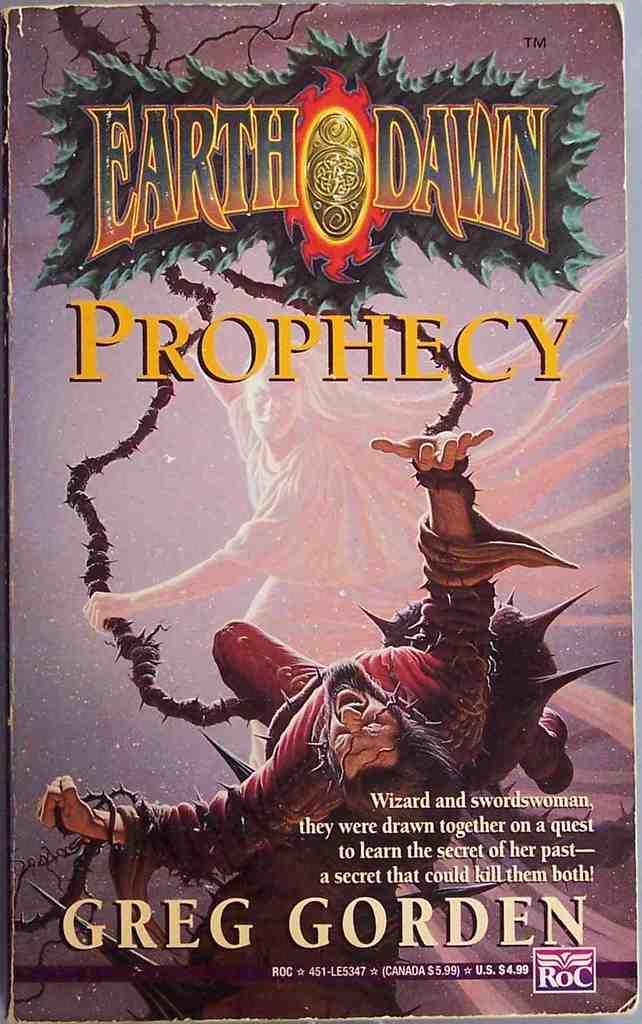What is the main subject in the center of the image? There is a poster in the center of the image. What can be found on the poster? The poster contains text and depicts a person. How many chickens are present in the image? There are no chickens present in the image; the poster contains text and depicts a person. What type of son is mentioned in the image? There is no mention of a son in the image; the poster contains text and depicts a person. 